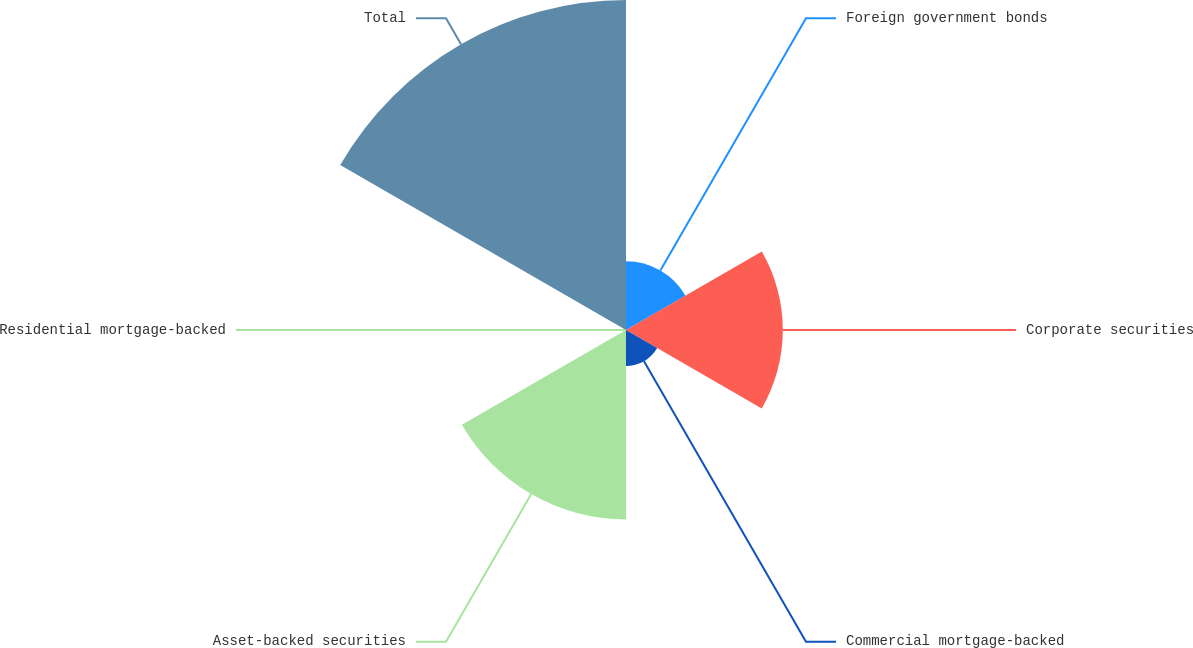Convert chart to OTSL. <chart><loc_0><loc_0><loc_500><loc_500><pie_chart><fcel>Foreign government bonds<fcel>Corporate securities<fcel>Commercial mortgage-backed<fcel>Asset-backed securities<fcel>Residential mortgage-backed<fcel>Total<nl><fcel>8.76%<fcel>19.99%<fcel>4.59%<fcel>24.16%<fcel>0.43%<fcel>42.07%<nl></chart> 